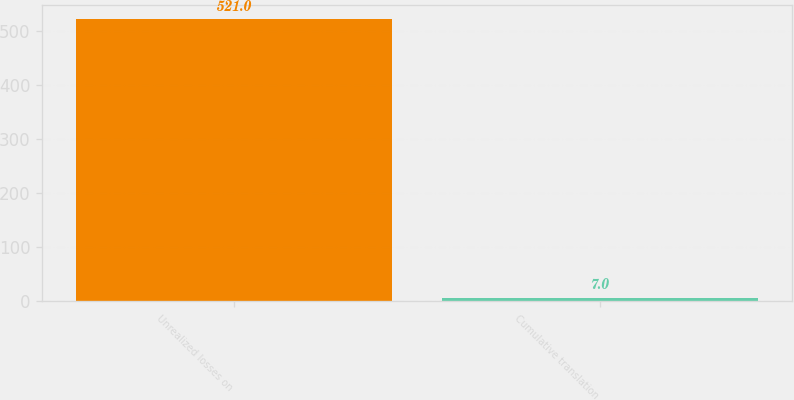<chart> <loc_0><loc_0><loc_500><loc_500><bar_chart><fcel>Unrealized losses on<fcel>Cumulative translation<nl><fcel>521<fcel>7<nl></chart> 